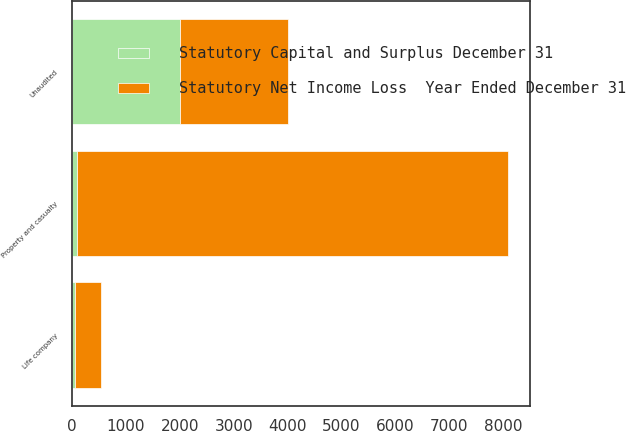<chart> <loc_0><loc_0><loc_500><loc_500><stacked_bar_chart><ecel><fcel>Unaudited<fcel>Property and casualty<fcel>Life company<nl><fcel>Statutory Net Income Loss  Year Ended December 31<fcel>2008<fcel>8002<fcel>487<nl><fcel>Statutory Capital and Surplus December 31<fcel>2008<fcel>89<fcel>51<nl></chart> 